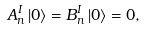<formula> <loc_0><loc_0><loc_500><loc_500>A _ { n } ^ { I } \left | 0 \right \rangle = B _ { n } ^ { I } \left | 0 \right \rangle = 0 ,</formula> 